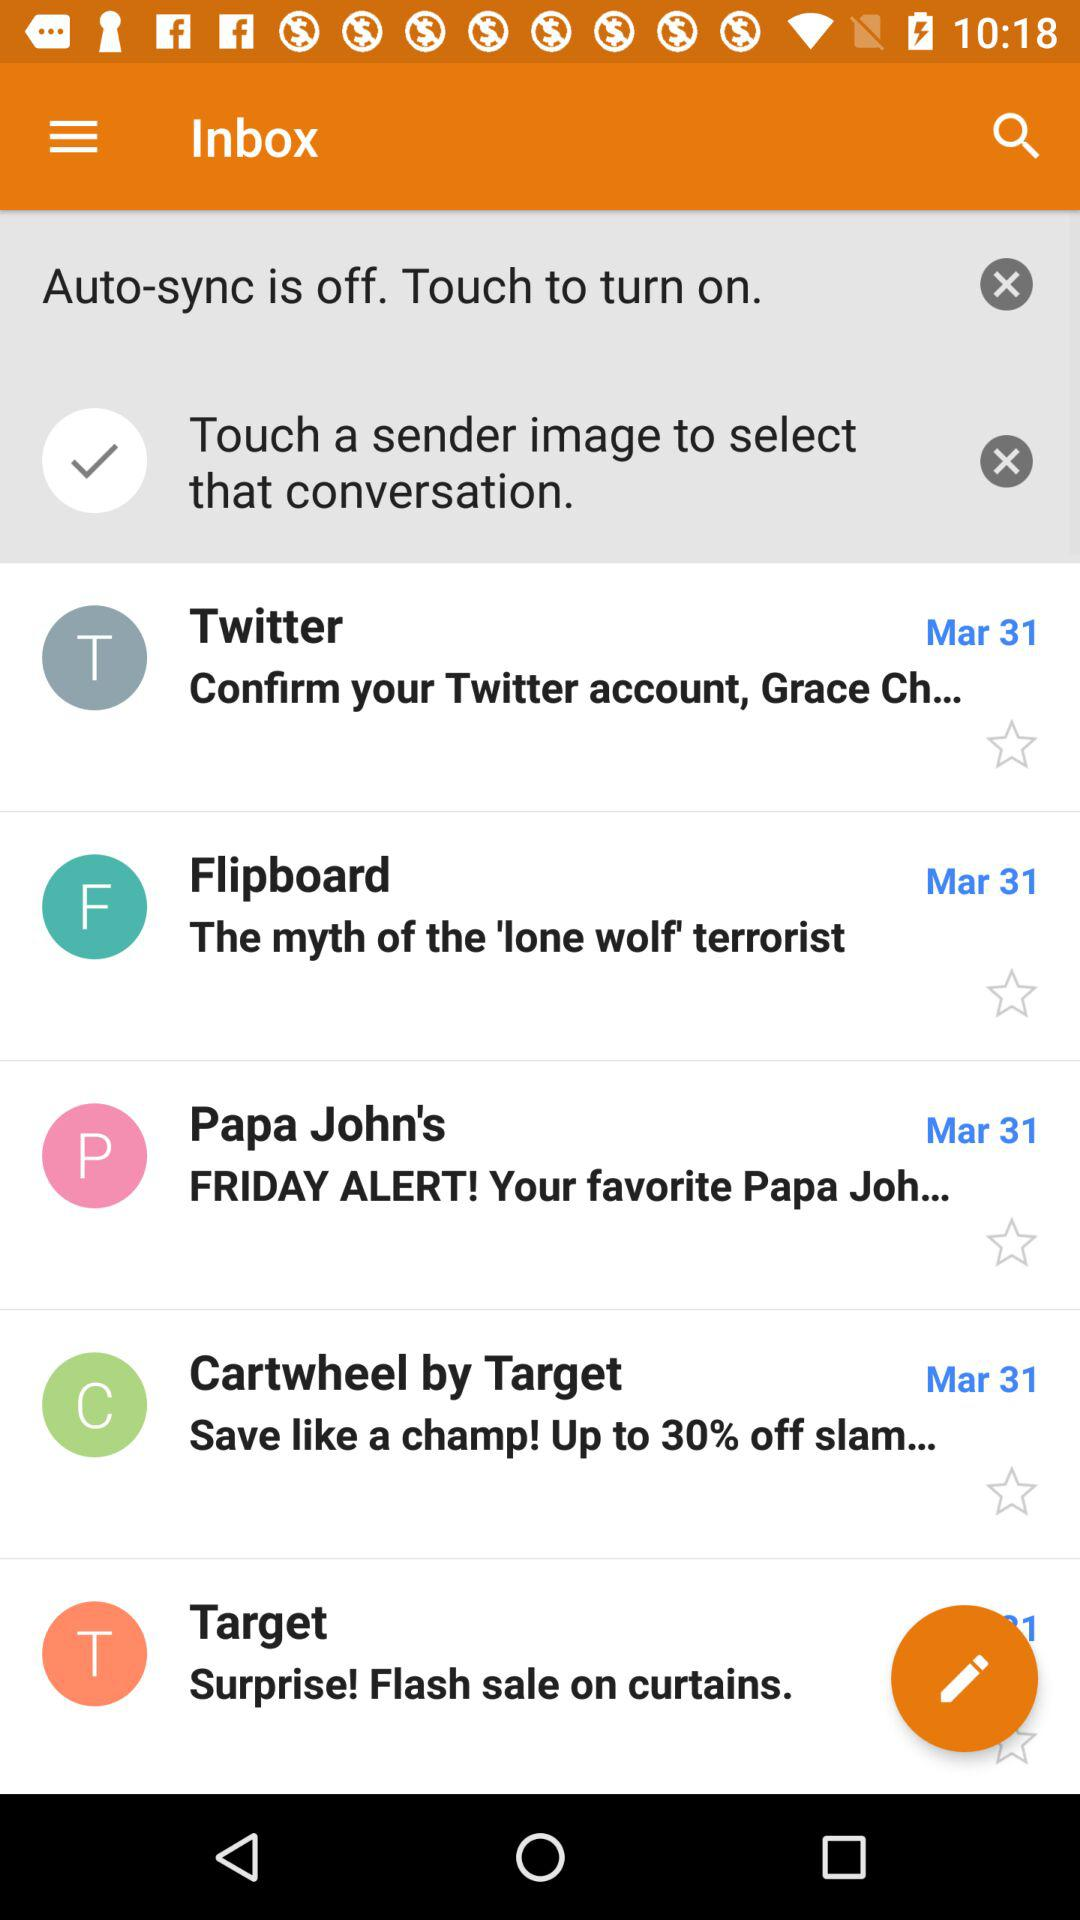What is the date of the message from Flipboard? The date is March 31. 